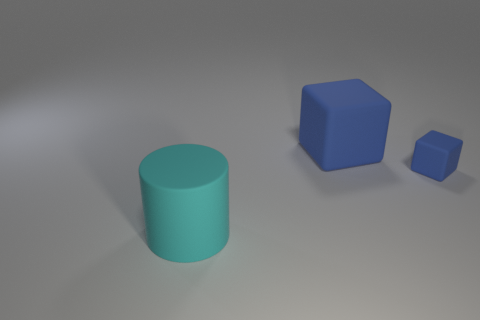What is the material of the tiny block that is the same color as the large cube?
Provide a short and direct response. Rubber. Are there any things of the same color as the large block?
Provide a short and direct response. Yes. What color is the rubber thing that is both right of the large cyan thing and to the left of the small rubber cube?
Your answer should be compact. Blue. What number of other cylinders are the same size as the cyan rubber cylinder?
Give a very brief answer. 0. Are the large thing that is behind the cyan matte cylinder and the object that is on the left side of the large block made of the same material?
Your answer should be very brief. Yes. The large blue object behind the rubber block that is in front of the big cube is made of what material?
Keep it short and to the point. Rubber. There is a cube that is to the right of the large rubber block; what is it made of?
Provide a short and direct response. Rubber. How many other blue objects are the same shape as the tiny matte thing?
Ensure brevity in your answer.  1. Do the large matte cylinder and the tiny cube have the same color?
Provide a succinct answer. No. What material is the thing that is left of the blue rubber object that is on the left side of the blue matte cube right of the big blue matte cube?
Keep it short and to the point. Rubber. 